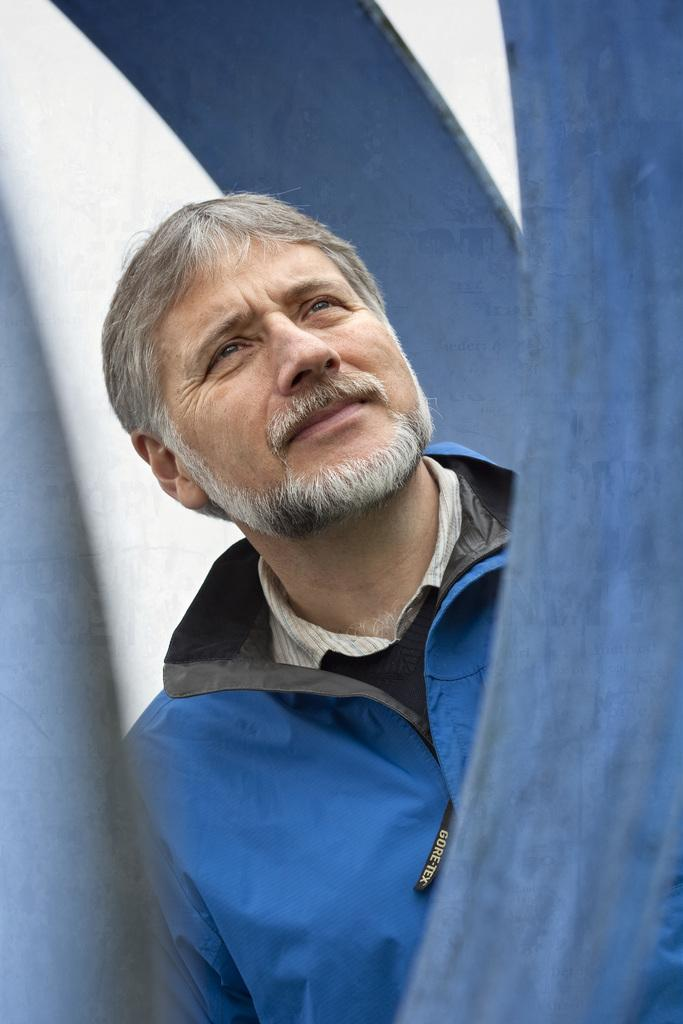Who is present in the image? There is a man in the image. What is the man wearing? The man is wearing a jacket. What color or type of objects can be seen in the image? There are blue objects in the image. What is the color of the background in the image? The background of the image is white. How does the man's digestion process appear in the image? There is no indication of the man's digestion process in the image. 